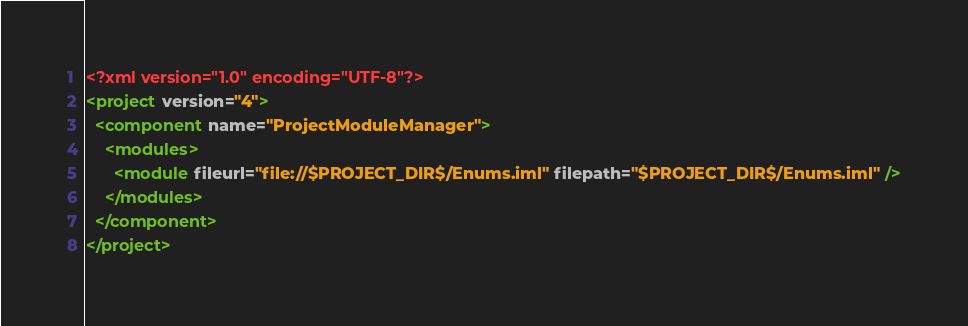<code> <loc_0><loc_0><loc_500><loc_500><_XML_><?xml version="1.0" encoding="UTF-8"?>
<project version="4">
  <component name="ProjectModuleManager">
    <modules>
      <module fileurl="file://$PROJECT_DIR$/Enums.iml" filepath="$PROJECT_DIR$/Enums.iml" />
    </modules>
  </component>
</project></code> 